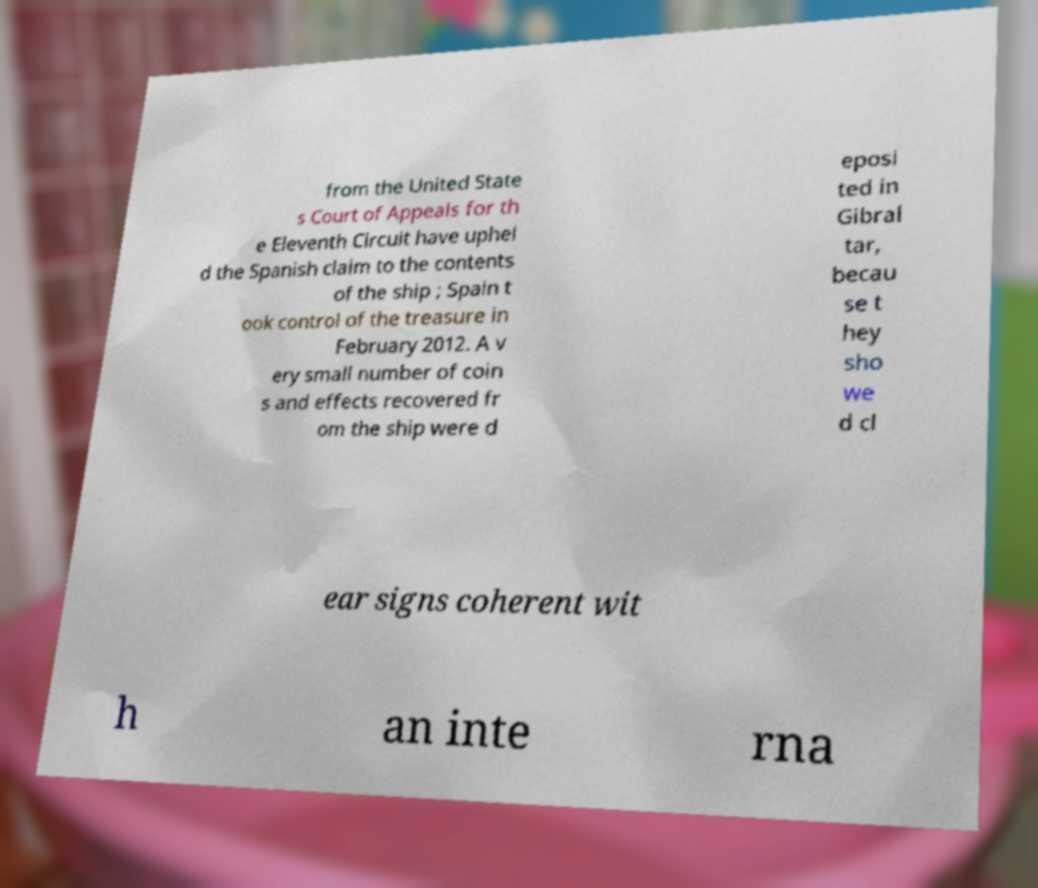There's text embedded in this image that I need extracted. Can you transcribe it verbatim? from the United State s Court of Appeals for th e Eleventh Circuit have uphel d the Spanish claim to the contents of the ship ; Spain t ook control of the treasure in February 2012. A v ery small number of coin s and effects recovered fr om the ship were d eposi ted in Gibral tar, becau se t hey sho we d cl ear signs coherent wit h an inte rna 